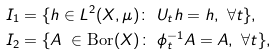Convert formula to latex. <formula><loc_0><loc_0><loc_500><loc_500>I _ { 1 } & = \{ h \in L ^ { 2 } ( X , \mu ) \colon \ U _ { t } h = h , \ \forall t \} , \\ I _ { 2 } & = \{ A \ \in \text {Bor} ( X ) \colon \ \phi _ { t } ^ { - 1 } A = A , \ \forall t \} ,</formula> 